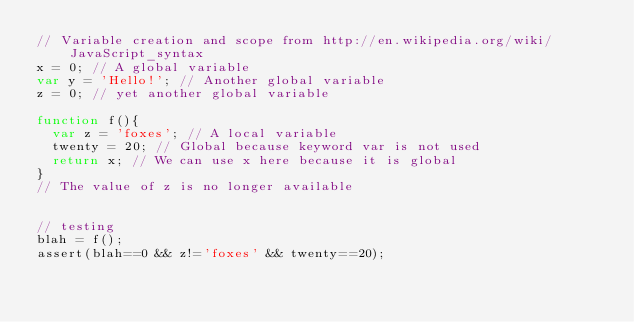<code> <loc_0><loc_0><loc_500><loc_500><_JavaScript_>// Variable creation and scope from http://en.wikipedia.org/wiki/JavaScript_syntax
x = 0; // A global variable
var y = 'Hello!'; // Another global variable
z = 0; // yet another global variable

function f(){
  var z = 'foxes'; // A local variable
  twenty = 20; // Global because keyword var is not used
  return x; // We can use x here because it is global
}
// The value of z is no longer available


// testing
blah = f();
assert(blah==0 && z!='foxes' && twenty==20);
</code> 